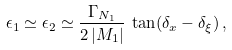<formula> <loc_0><loc_0><loc_500><loc_500>\epsilon _ { 1 } \simeq \epsilon _ { 2 } \simeq \frac { \Gamma _ { N _ { 1 } } } { 2 \left | M _ { 1 } \right | } \, \tan ( \delta _ { x } - \delta _ { \xi } ) \, ,</formula> 